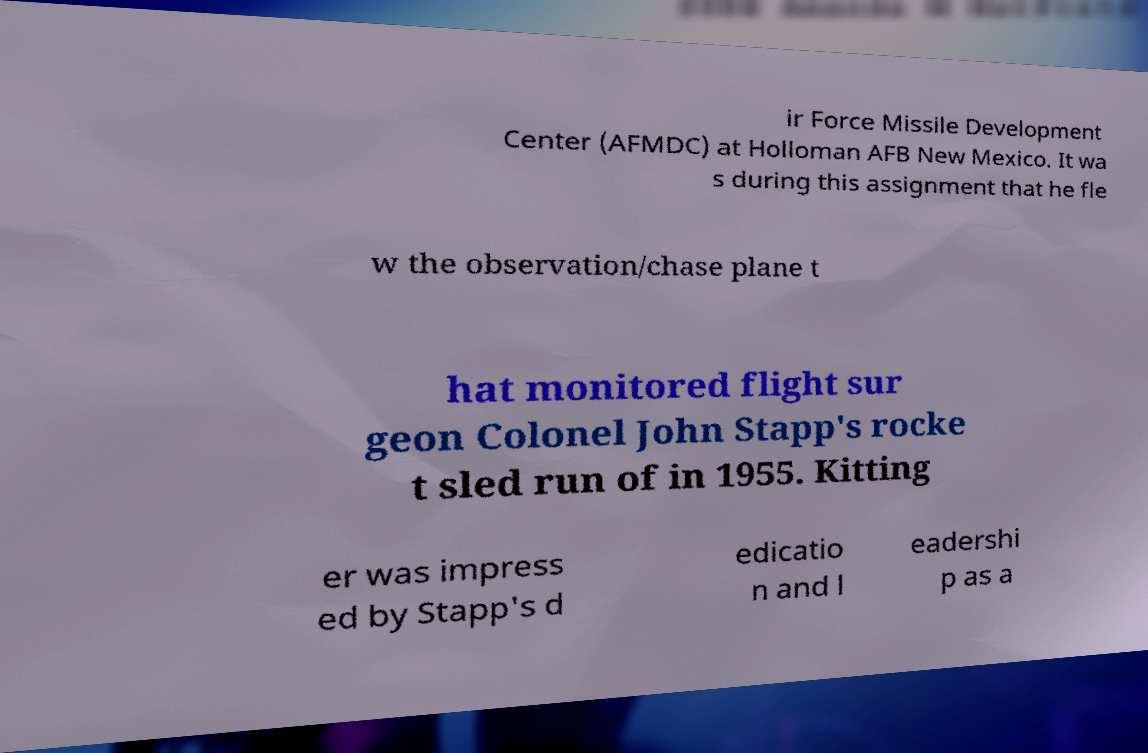Can you read and provide the text displayed in the image?This photo seems to have some interesting text. Can you extract and type it out for me? ir Force Missile Development Center (AFMDC) at Holloman AFB New Mexico. It wa s during this assignment that he fle w the observation/chase plane t hat monitored flight sur geon Colonel John Stapp's rocke t sled run of in 1955. Kitting er was impress ed by Stapp's d edicatio n and l eadershi p as a 